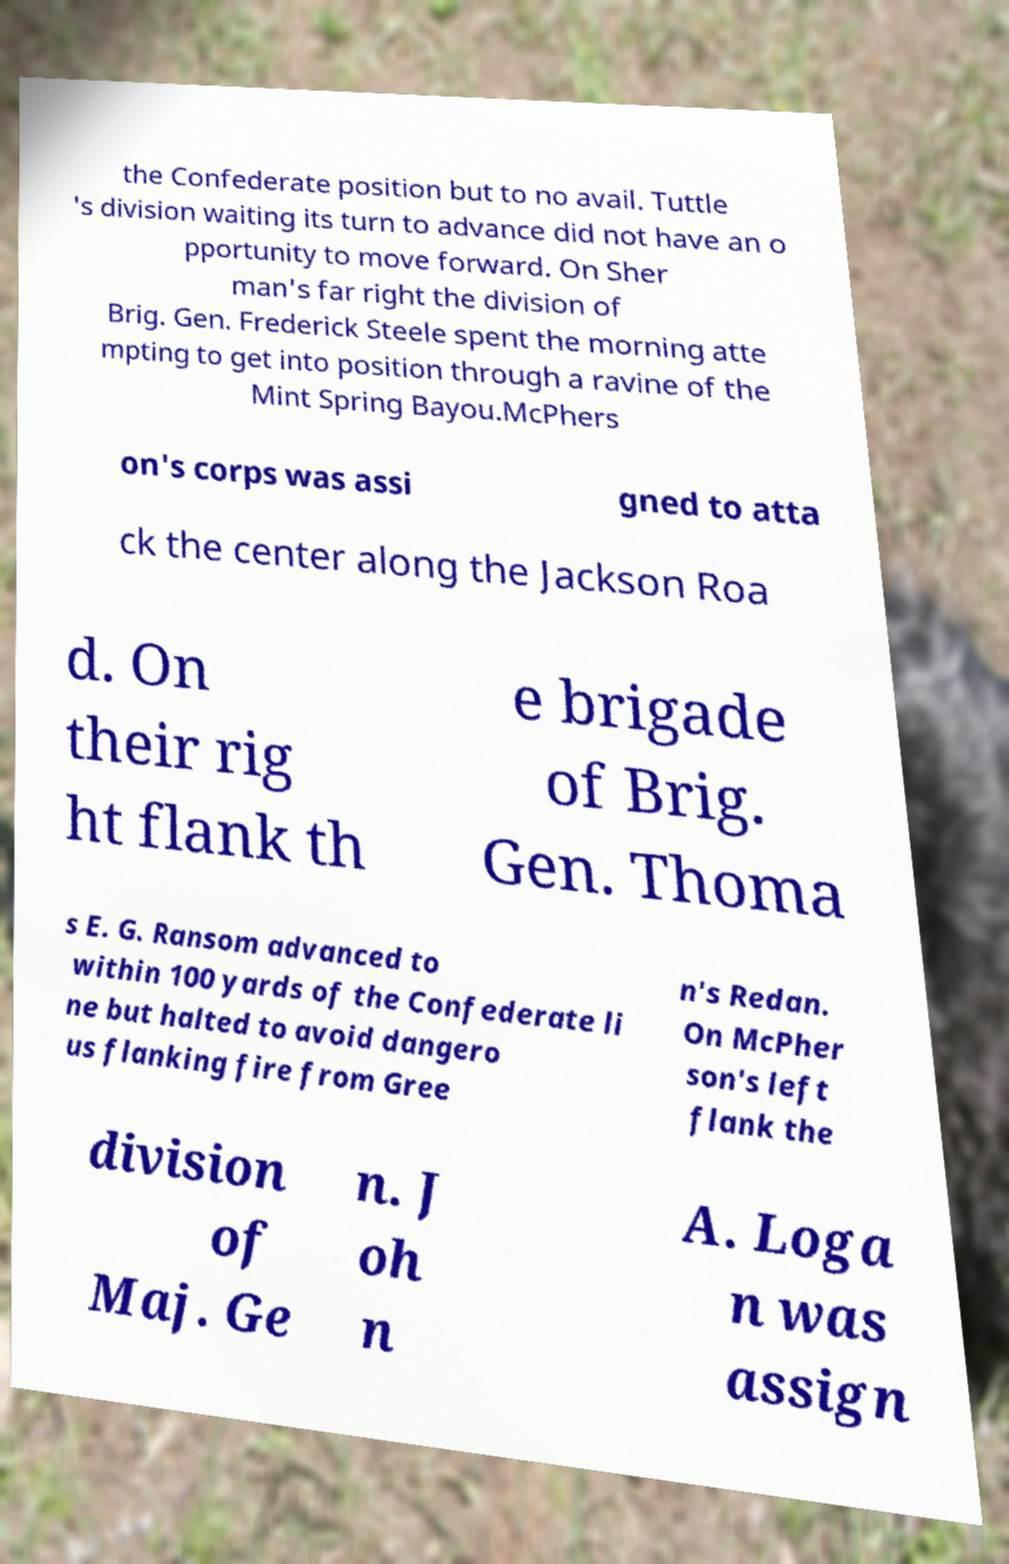I need the written content from this picture converted into text. Can you do that? the Confederate position but to no avail. Tuttle 's division waiting its turn to advance did not have an o pportunity to move forward. On Sher man's far right the division of Brig. Gen. Frederick Steele spent the morning atte mpting to get into position through a ravine of the Mint Spring Bayou.McPhers on's corps was assi gned to atta ck the center along the Jackson Roa d. On their rig ht flank th e brigade of Brig. Gen. Thoma s E. G. Ransom advanced to within 100 yards of the Confederate li ne but halted to avoid dangero us flanking fire from Gree n's Redan. On McPher son's left flank the division of Maj. Ge n. J oh n A. Loga n was assign 